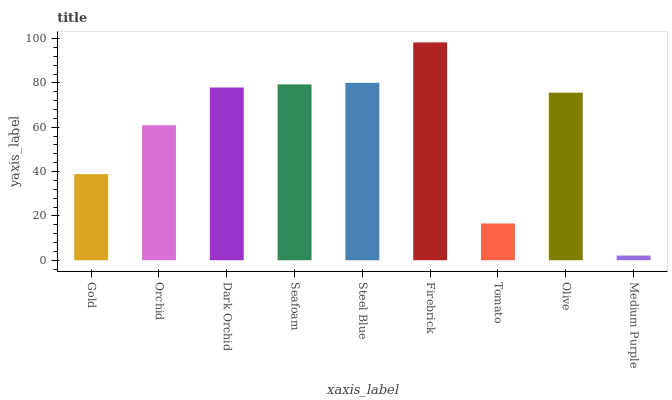Is Medium Purple the minimum?
Answer yes or no. Yes. Is Firebrick the maximum?
Answer yes or no. Yes. Is Orchid the minimum?
Answer yes or no. No. Is Orchid the maximum?
Answer yes or no. No. Is Orchid greater than Gold?
Answer yes or no. Yes. Is Gold less than Orchid?
Answer yes or no. Yes. Is Gold greater than Orchid?
Answer yes or no. No. Is Orchid less than Gold?
Answer yes or no. No. Is Olive the high median?
Answer yes or no. Yes. Is Olive the low median?
Answer yes or no. Yes. Is Orchid the high median?
Answer yes or no. No. Is Tomato the low median?
Answer yes or no. No. 